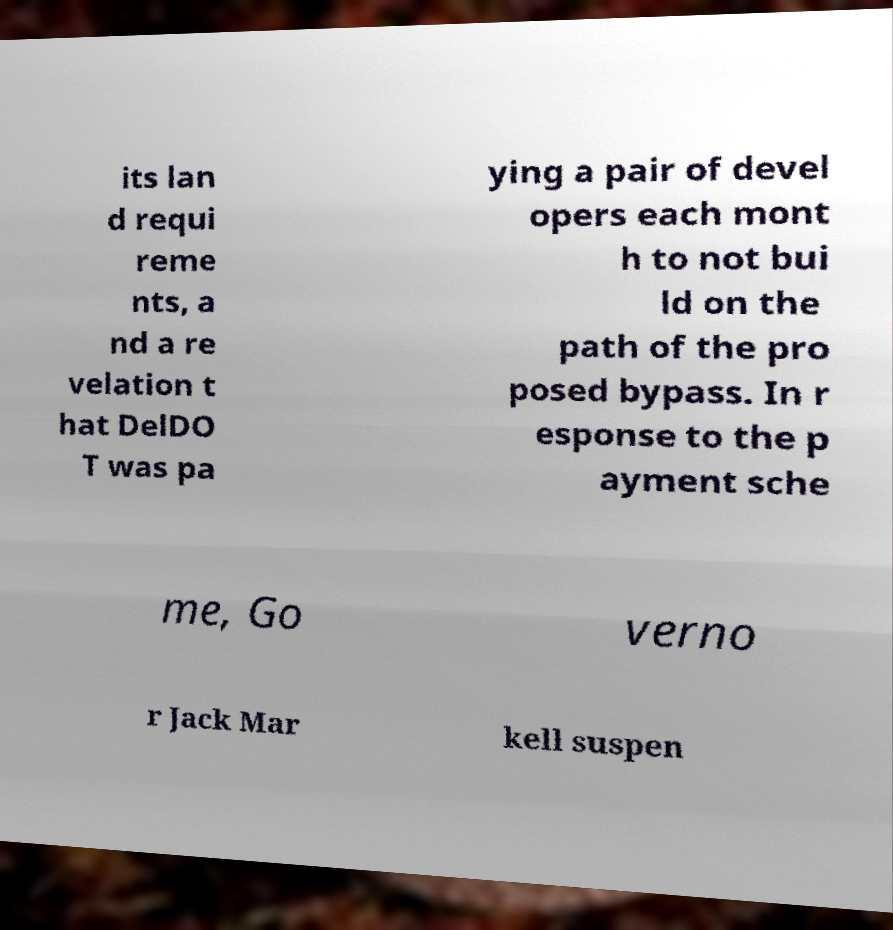What messages or text are displayed in this image? I need them in a readable, typed format. its lan d requi reme nts, a nd a re velation t hat DelDO T was pa ying a pair of devel opers each mont h to not bui ld on the path of the pro posed bypass. In r esponse to the p ayment sche me, Go verno r Jack Mar kell suspen 